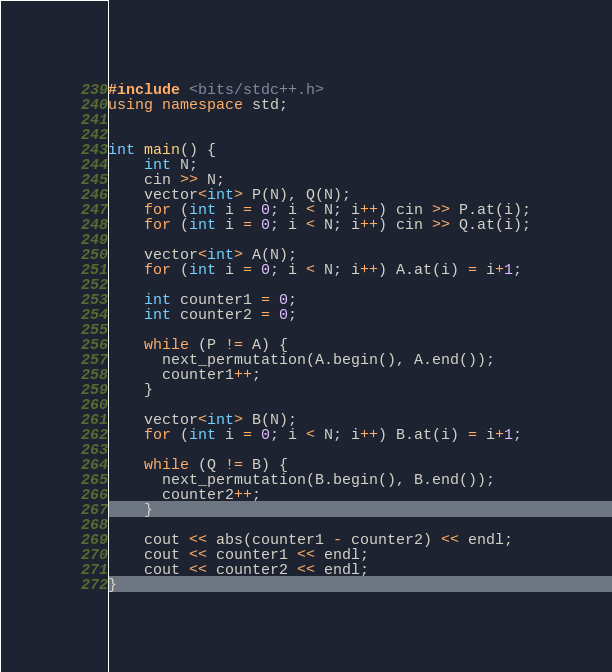<code> <loc_0><loc_0><loc_500><loc_500><_C++_>#include <bits/stdc++.h>
using namespace std;


int main() {
    int N;
    cin >> N;
    vector<int> P(N), Q(N);
    for (int i = 0; i < N; i++) cin >> P.at(i);
    for (int i = 0; i < N; i++) cin >> Q.at(i);
    
    vector<int> A(N);
    for (int i = 0; i < N; i++) A.at(i) = i+1;
    
    int counter1 = 0;
    int counter2 = 0;

    while (P != A) {
      next_permutation(A.begin(), A.end());
      counter1++;
    }

    vector<int> B(N);
    for (int i = 0; i < N; i++) B.at(i) = i+1;

    while (Q != B) {
      next_permutation(B.begin(), B.end());
      counter2++;
    }

    cout << abs(counter1 - counter2) << endl;
    cout << counter1 << endl;
    cout << counter2 << endl;
}</code> 